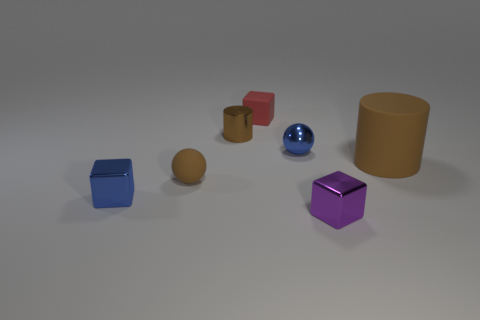What size is the other rubber object that is the same color as the big thing?
Ensure brevity in your answer.  Small. Does the cylinder to the right of the purple metal block have the same material as the cube that is behind the brown metallic cylinder?
Your answer should be compact. Yes. There is a brown matte object that is in front of the large brown object; what shape is it?
Make the answer very short. Sphere. Are there fewer cylinders than big purple matte spheres?
Offer a terse response. No. There is a small block that is in front of the blue object on the left side of the red cube; are there any blue cubes that are on the right side of it?
Your answer should be compact. No. What number of matte objects are big cylinders or tiny red cylinders?
Provide a short and direct response. 1. Do the big matte cylinder and the tiny cylinder have the same color?
Offer a very short reply. Yes. There is a brown metallic cylinder; what number of tiny brown cylinders are on the left side of it?
Your response must be concise. 0. What number of matte things are in front of the blue sphere and on the left side of the large object?
Make the answer very short. 1. What shape is the tiny purple object that is the same material as the tiny brown cylinder?
Ensure brevity in your answer.  Cube. 